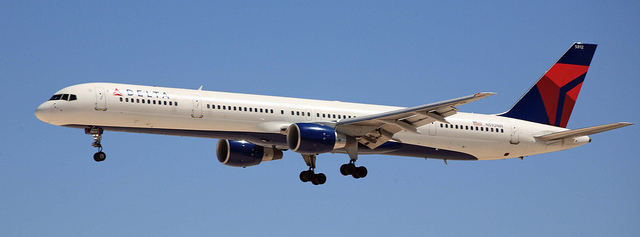Please extract the text content from this image. DELTA 